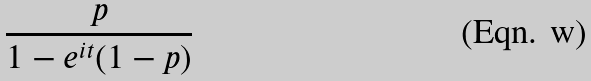<formula> <loc_0><loc_0><loc_500><loc_500>\frac { p } { 1 - e ^ { i t } ( 1 - p ) }</formula> 